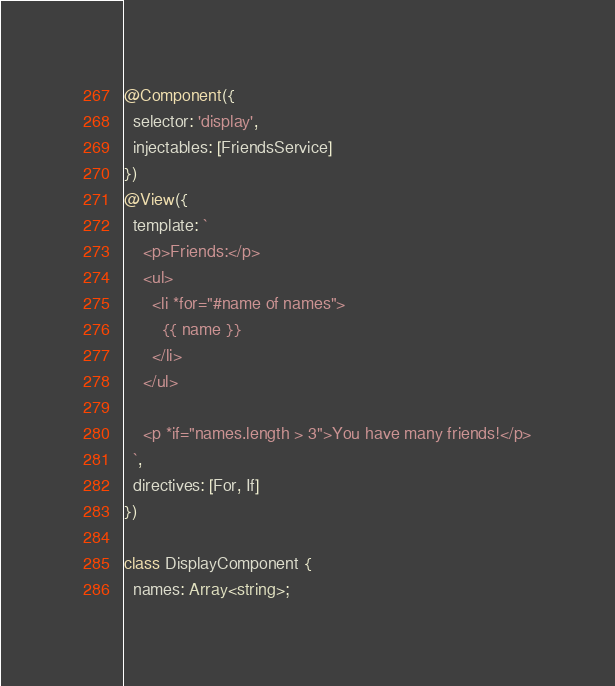Convert code to text. <code><loc_0><loc_0><loc_500><loc_500><_TypeScript_>@Component({
  selector: 'display',
  injectables: [FriendsService]
})
@View({
  template: `
    <p>Friends:</p>
    <ul>
      <li *for="#name of names">
        {{ name }}
      </li>
    </ul>

    <p *if="names.length > 3">You have many friends!</p>
  `,
  directives: [For, If]
})

class DisplayComponent {
  names: Array<string>;
</code> 